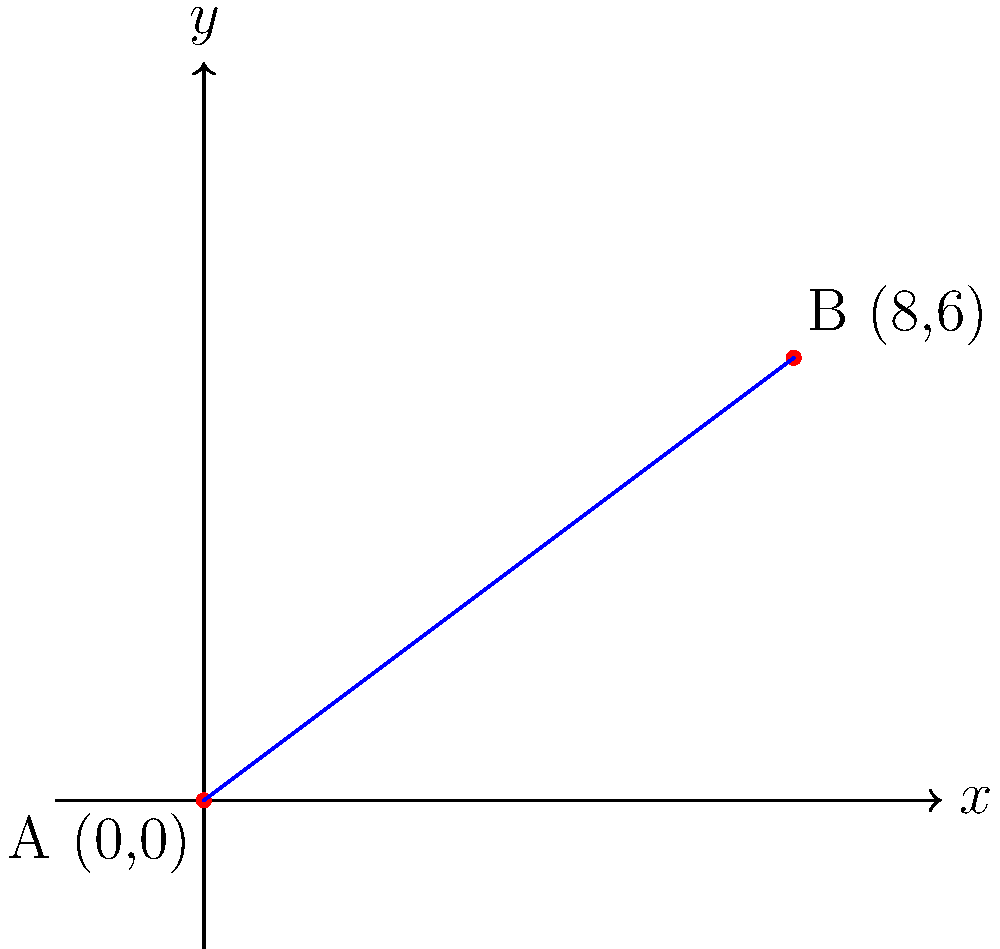G'day, radio enthusiasts! Let's take a trip down memory lane to the days when we'd plot our signal trajectories by hand. Imagine two broadcasting towers, A and B, on a coordinate plane. Tower A is located at the origin (0,0), and Tower B is at (8,6). What's the slope of the line representing the direct signal path between these two towers? Round your answer to two decimal places. Alright, let's break this down step-by-step, just like we used to do it in the good old days:

1) To find the slope of a line, we use the formula:

   $$ m = \frac{y_2 - y_1}{x_2 - x_1} $$

   Where $(x_1, y_1)$ is the first point and $(x_2, y_2)$ is the second point.

2) In our case:
   - Point A (first point): $(x_1, y_1) = (0, 0)$
   - Point B (second point): $(x_2, y_2) = (8, 6)$

3) Let's plug these into our formula:

   $$ m = \frac{6 - 0}{8 - 0} = \frac{6}{8} $$

4) Now, let's simplify this fraction:

   $$ \frac{6}{8} = \frac{3}{4} = 0.75 $$

5) The question asks for the answer rounded to two decimal places, but 0.75 is already in that form.

So, there you have it! The slope of our signal path is 0.75, or 75%. This means for every 4 units we move horizontally, our signal rises 3 units vertically. Quite a steady climb, wouldn't you say?
Answer: 0.75 